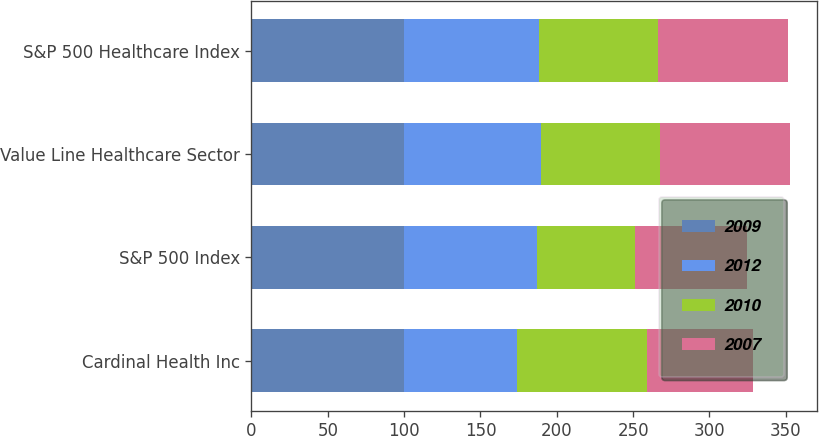Convert chart to OTSL. <chart><loc_0><loc_0><loc_500><loc_500><stacked_bar_chart><ecel><fcel>Cardinal Health Inc<fcel>S&P 500 Index<fcel>Value Line Healthcare Sector<fcel>S&P 500 Healthcare Index<nl><fcel>2009<fcel>100<fcel>100<fcel>100<fcel>100<nl><fcel>2012<fcel>73.68<fcel>86.88<fcel>89.88<fcel>88.28<nl><fcel>2010<fcel>85.2<fcel>64.11<fcel>77.82<fcel>78.15<nl><fcel>2007<fcel>69.56<fcel>73.36<fcel>85.2<fcel>85.18<nl></chart> 